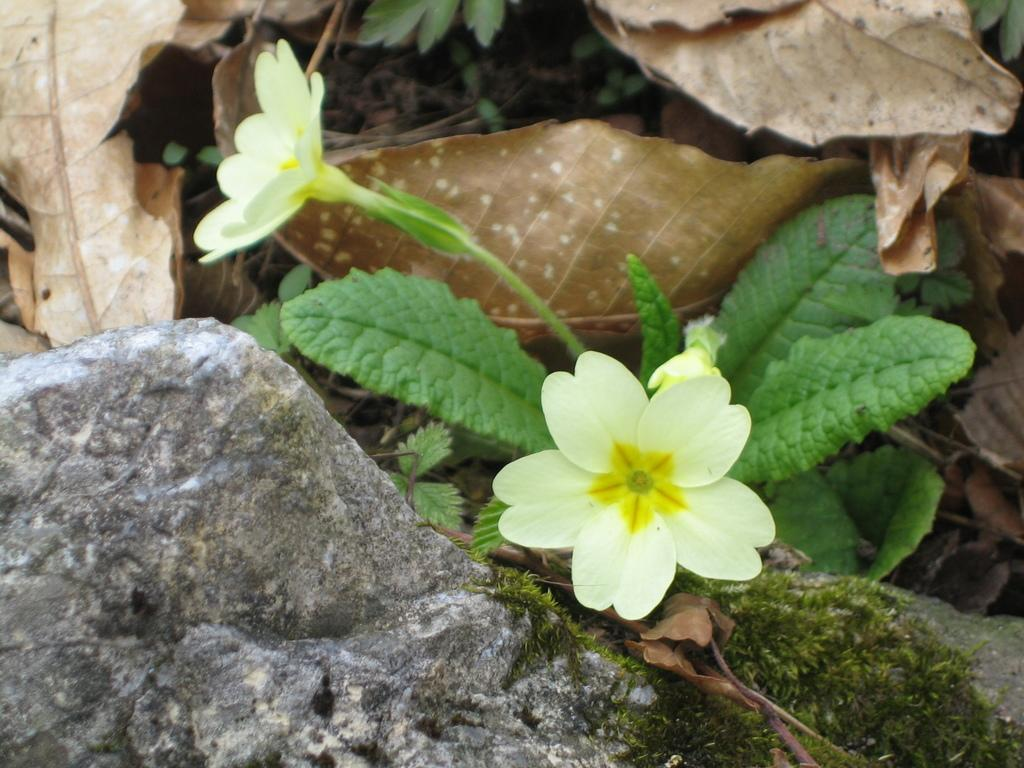How many flowers are on the plant in the image? There are two flowers on the stem of a plant in the image. What can be seen in the background of the image? There are dried leaves and stones in the background of the image. What time of day is it in the image? The time of day cannot be determined from the image, as there are no clues or indicators present. 